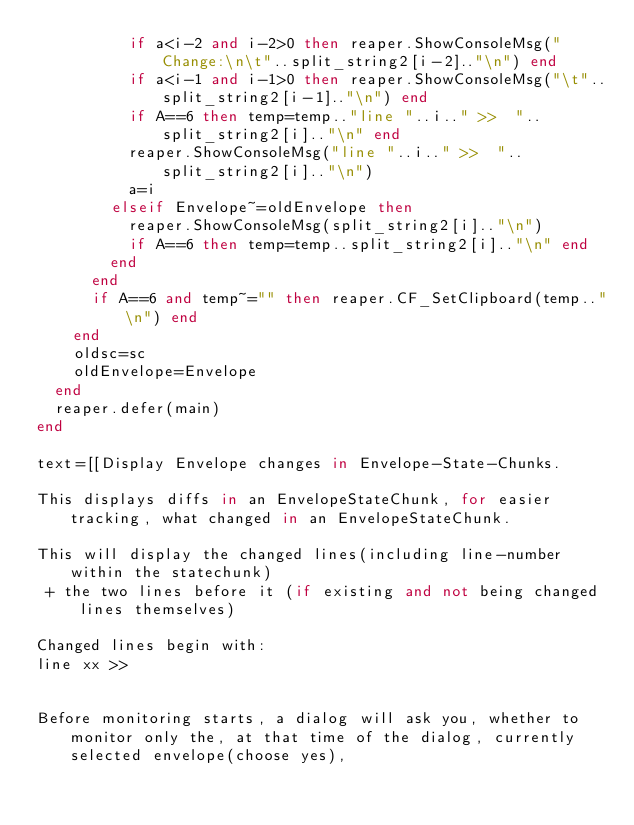<code> <loc_0><loc_0><loc_500><loc_500><_Lua_>          if a<i-2 and i-2>0 then reaper.ShowConsoleMsg("Change:\n\t"..split_string2[i-2].."\n") end
          if a<i-1 and i-1>0 then reaper.ShowConsoleMsg("\t"..split_string2[i-1].."\n") end
          if A==6 then temp=temp.."line "..i.." >>  "..split_string2[i].."\n" end
          reaper.ShowConsoleMsg("line "..i.." >>  "..split_string2[i].."\n")
          a=i
        elseif Envelope~=oldEnvelope then
          reaper.ShowConsoleMsg(split_string2[i].."\n")
          if A==6 then temp=temp..split_string2[i].."\n" end
        end        
      end
      if A==6 and temp~="" then reaper.CF_SetClipboard(temp.."\n") end
    end
    oldsc=sc
    oldEnvelope=Envelope
  end
  reaper.defer(main)
end

text=[[Display Envelope changes in Envelope-State-Chunks.
  
This displays diffs in an EnvelopeStateChunk, for easier tracking, what changed in an EnvelopeStateChunk.

This will display the changed lines(including line-number within the statechunk)
 + the two lines before it (if existing and not being changed lines themselves)

Changed lines begin with:
line xx >>  


Before monitoring starts, a dialog will ask you, whether to monitor only the, at that time of the dialog, currently selected envelope(choose yes), </code> 